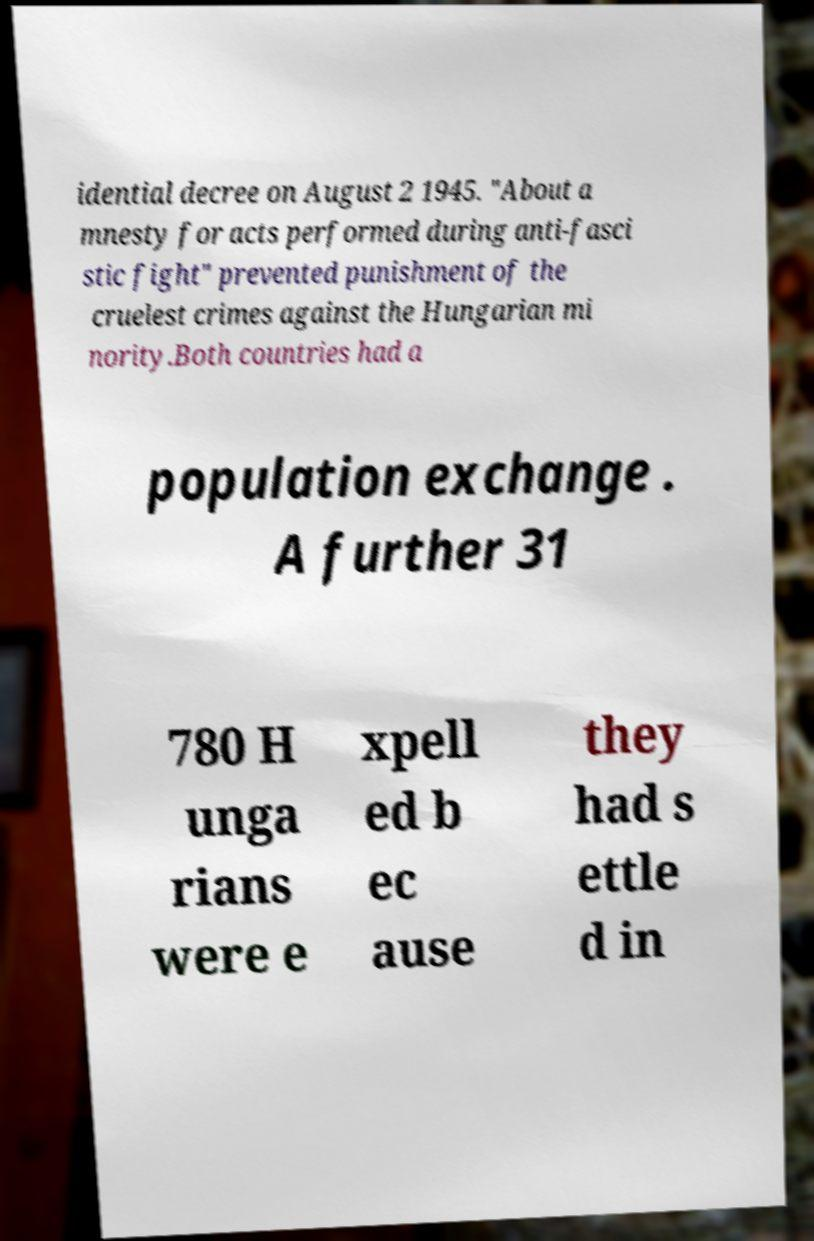Please read and relay the text visible in this image. What does it say? idential decree on August 2 1945. "About a mnesty for acts performed during anti-fasci stic fight" prevented punishment of the cruelest crimes against the Hungarian mi nority.Both countries had a population exchange . A further 31 780 H unga rians were e xpell ed b ec ause they had s ettle d in 